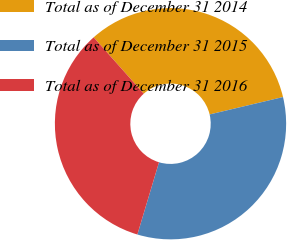Convert chart. <chart><loc_0><loc_0><loc_500><loc_500><pie_chart><fcel>Total as of December 31 2014<fcel>Total as of December 31 2015<fcel>Total as of December 31 2016<nl><fcel>32.86%<fcel>33.33%<fcel>33.8%<nl></chart> 